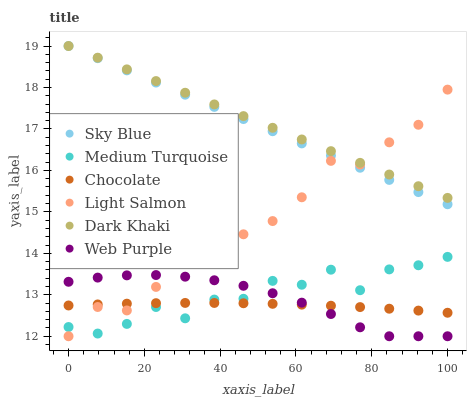Does Chocolate have the minimum area under the curve?
Answer yes or no. Yes. Does Dark Khaki have the maximum area under the curve?
Answer yes or no. Yes. Does Dark Khaki have the minimum area under the curve?
Answer yes or no. No. Does Chocolate have the maximum area under the curve?
Answer yes or no. No. Is Sky Blue the smoothest?
Answer yes or no. Yes. Is Light Salmon the roughest?
Answer yes or no. Yes. Is Chocolate the smoothest?
Answer yes or no. No. Is Chocolate the roughest?
Answer yes or no. No. Does Light Salmon have the lowest value?
Answer yes or no. Yes. Does Chocolate have the lowest value?
Answer yes or no. No. Does Sky Blue have the highest value?
Answer yes or no. Yes. Does Chocolate have the highest value?
Answer yes or no. No. Is Chocolate less than Sky Blue?
Answer yes or no. Yes. Is Dark Khaki greater than Medium Turquoise?
Answer yes or no. Yes. Does Light Salmon intersect Dark Khaki?
Answer yes or no. Yes. Is Light Salmon less than Dark Khaki?
Answer yes or no. No. Is Light Salmon greater than Dark Khaki?
Answer yes or no. No. Does Chocolate intersect Sky Blue?
Answer yes or no. No. 